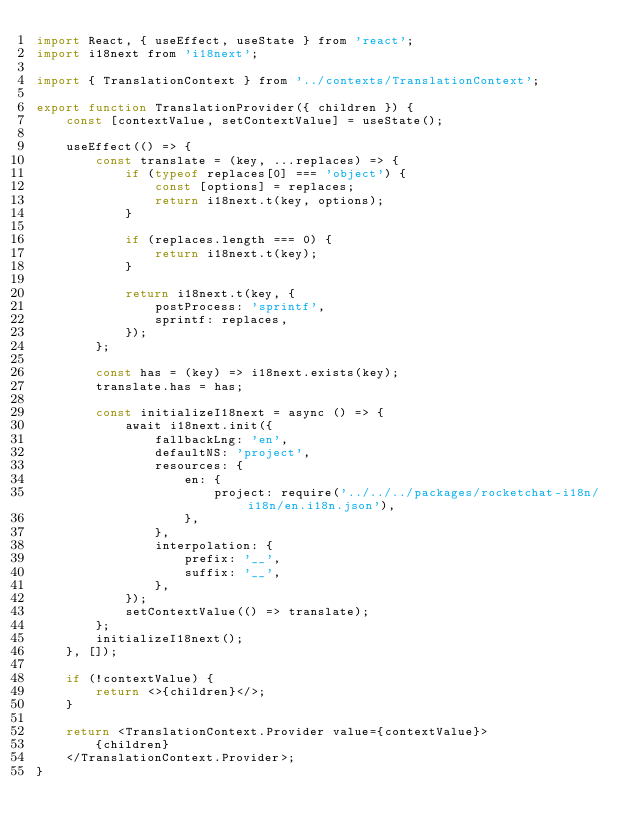Convert code to text. <code><loc_0><loc_0><loc_500><loc_500><_JavaScript_>import React, { useEffect, useState } from 'react';
import i18next from 'i18next';

import { TranslationContext } from '../contexts/TranslationContext';

export function TranslationProvider({ children }) {
	const [contextValue, setContextValue] = useState();

	useEffect(() => {
		const translate = (key, ...replaces) => {
			if (typeof replaces[0] === 'object') {
				const [options] = replaces;
				return i18next.t(key, options);
			}

			if (replaces.length === 0) {
				return i18next.t(key);
			}

			return i18next.t(key, {
				postProcess: 'sprintf',
				sprintf: replaces,
			});
		};

		const has = (key) => i18next.exists(key);
		translate.has = has;

		const initializeI18next = async () => {
			await i18next.init({
				fallbackLng: 'en',
				defaultNS: 'project',
				resources: {
					en: {
						project: require('../../../packages/rocketchat-i18n/i18n/en.i18n.json'),
					},
				},
				interpolation: {
					prefix: '__',
					suffix: '__',
				},
			});
			setContextValue(() => translate);
		};
		initializeI18next();
	}, []);

	if (!contextValue) {
		return <>{children}</>;
	}

	return <TranslationContext.Provider value={contextValue}>
		{children}
	</TranslationContext.Provider>;
}
</code> 